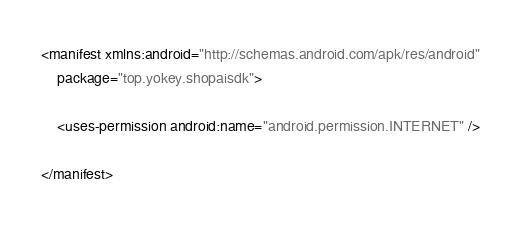<code> <loc_0><loc_0><loc_500><loc_500><_XML_>
<manifest xmlns:android="http://schemas.android.com/apk/res/android"
    package="top.yokey.shopaisdk">

    <uses-permission android:name="android.permission.INTERNET" />

</manifest>
</code> 